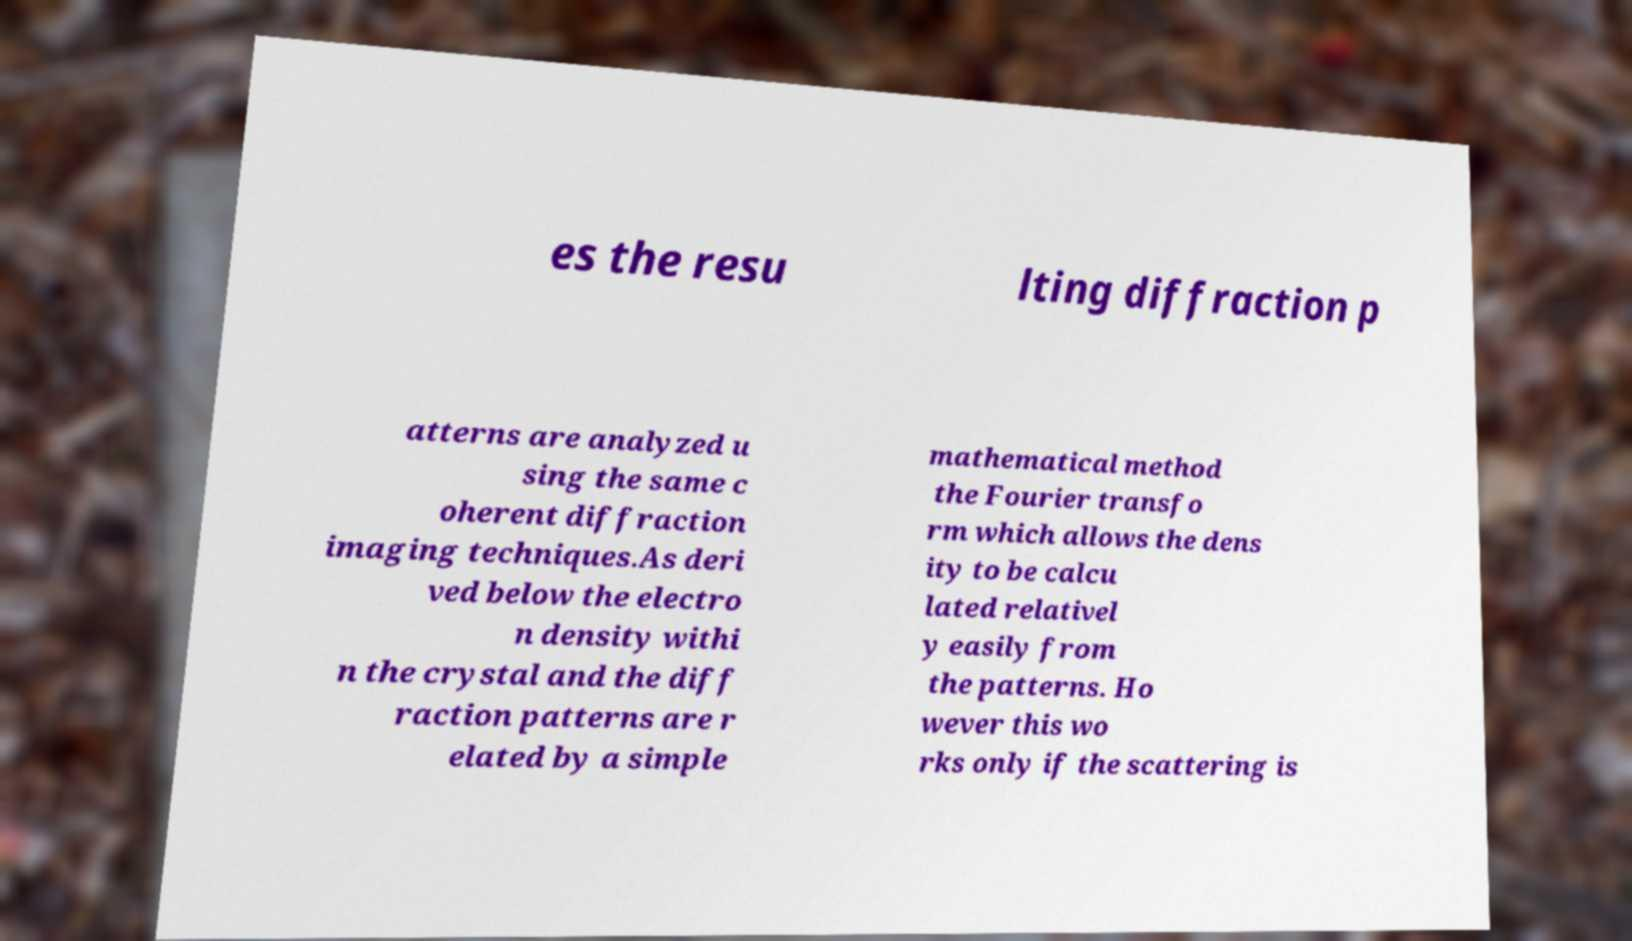Please read and relay the text visible in this image. What does it say? es the resu lting diffraction p atterns are analyzed u sing the same c oherent diffraction imaging techniques.As deri ved below the electro n density withi n the crystal and the diff raction patterns are r elated by a simple mathematical method the Fourier transfo rm which allows the dens ity to be calcu lated relativel y easily from the patterns. Ho wever this wo rks only if the scattering is 